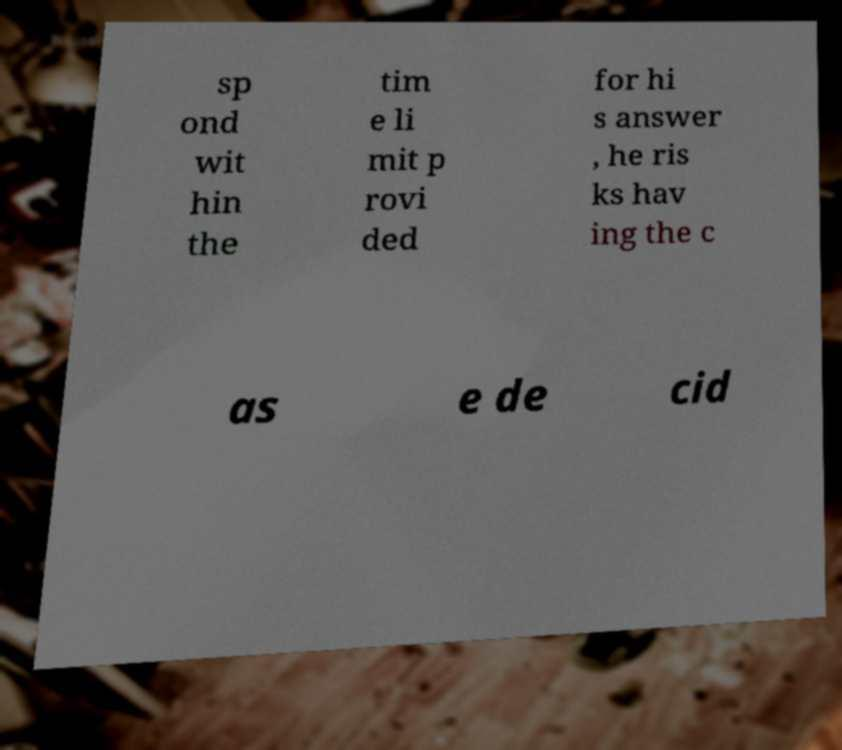Could you assist in decoding the text presented in this image and type it out clearly? sp ond wit hin the tim e li mit p rovi ded for hi s answer , he ris ks hav ing the c as e de cid 